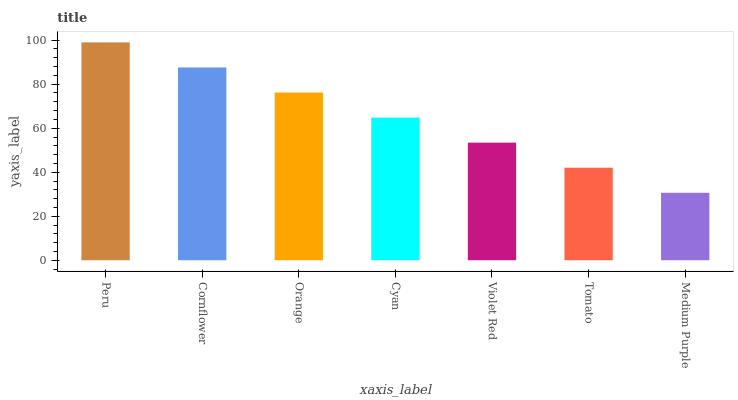Is Medium Purple the minimum?
Answer yes or no. Yes. Is Peru the maximum?
Answer yes or no. Yes. Is Cornflower the minimum?
Answer yes or no. No. Is Cornflower the maximum?
Answer yes or no. No. Is Peru greater than Cornflower?
Answer yes or no. Yes. Is Cornflower less than Peru?
Answer yes or no. Yes. Is Cornflower greater than Peru?
Answer yes or no. No. Is Peru less than Cornflower?
Answer yes or no. No. Is Cyan the high median?
Answer yes or no. Yes. Is Cyan the low median?
Answer yes or no. Yes. Is Orange the high median?
Answer yes or no. No. Is Violet Red the low median?
Answer yes or no. No. 